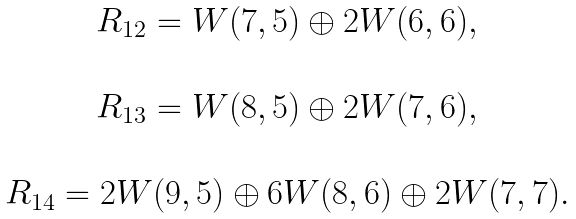<formula> <loc_0><loc_0><loc_500><loc_500>\begin{array} { c } R _ { 1 2 } = W ( 7 , 5 ) \oplus 2 W ( 6 , 6 ) , \\ \\ R _ { 1 3 } = W ( 8 , 5 ) \oplus 2 W ( 7 , 6 ) , \\ \\ R _ { 1 4 } = 2 W ( 9 , 5 ) \oplus 6 W ( 8 , 6 ) \oplus 2 W ( 7 , 7 ) . \\ \end{array}</formula> 